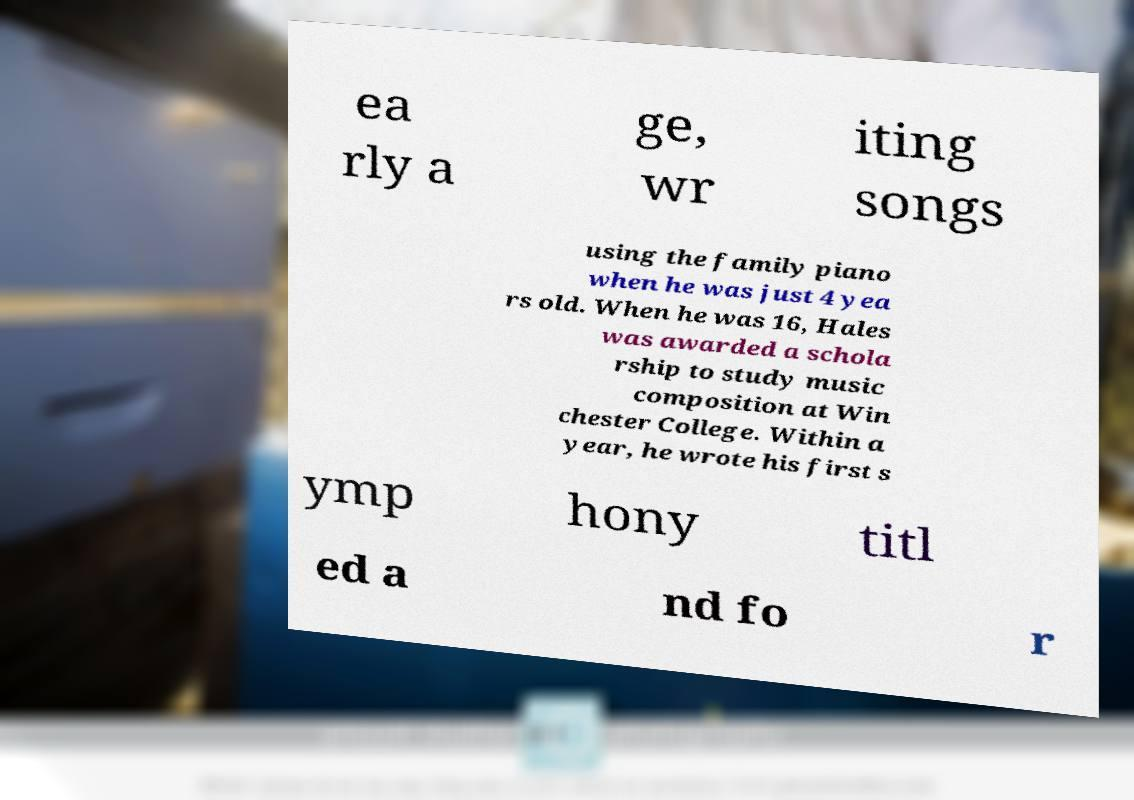There's text embedded in this image that I need extracted. Can you transcribe it verbatim? ea rly a ge, wr iting songs using the family piano when he was just 4 yea rs old. When he was 16, Hales was awarded a schola rship to study music composition at Win chester College. Within a year, he wrote his first s ymp hony titl ed a nd fo r 